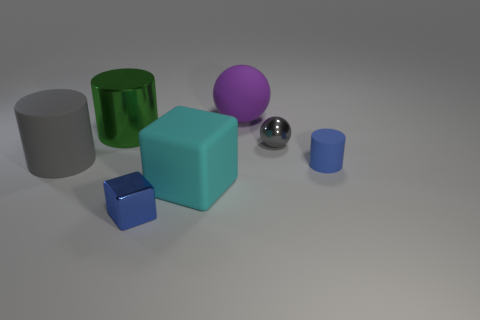Subtract all green cylinders. How many cylinders are left? 2 Add 3 large purple rubber cylinders. How many objects exist? 10 Subtract all cyan blocks. How many blocks are left? 1 Subtract 1 spheres. How many spheres are left? 1 Subtract all cyan rubber cubes. Subtract all big rubber objects. How many objects are left? 3 Add 2 cyan matte cubes. How many cyan matte cubes are left? 3 Add 2 gray cylinders. How many gray cylinders exist? 3 Subtract 0 cyan cylinders. How many objects are left? 7 Subtract all cylinders. How many objects are left? 4 Subtract all green cylinders. Subtract all cyan blocks. How many cylinders are left? 2 